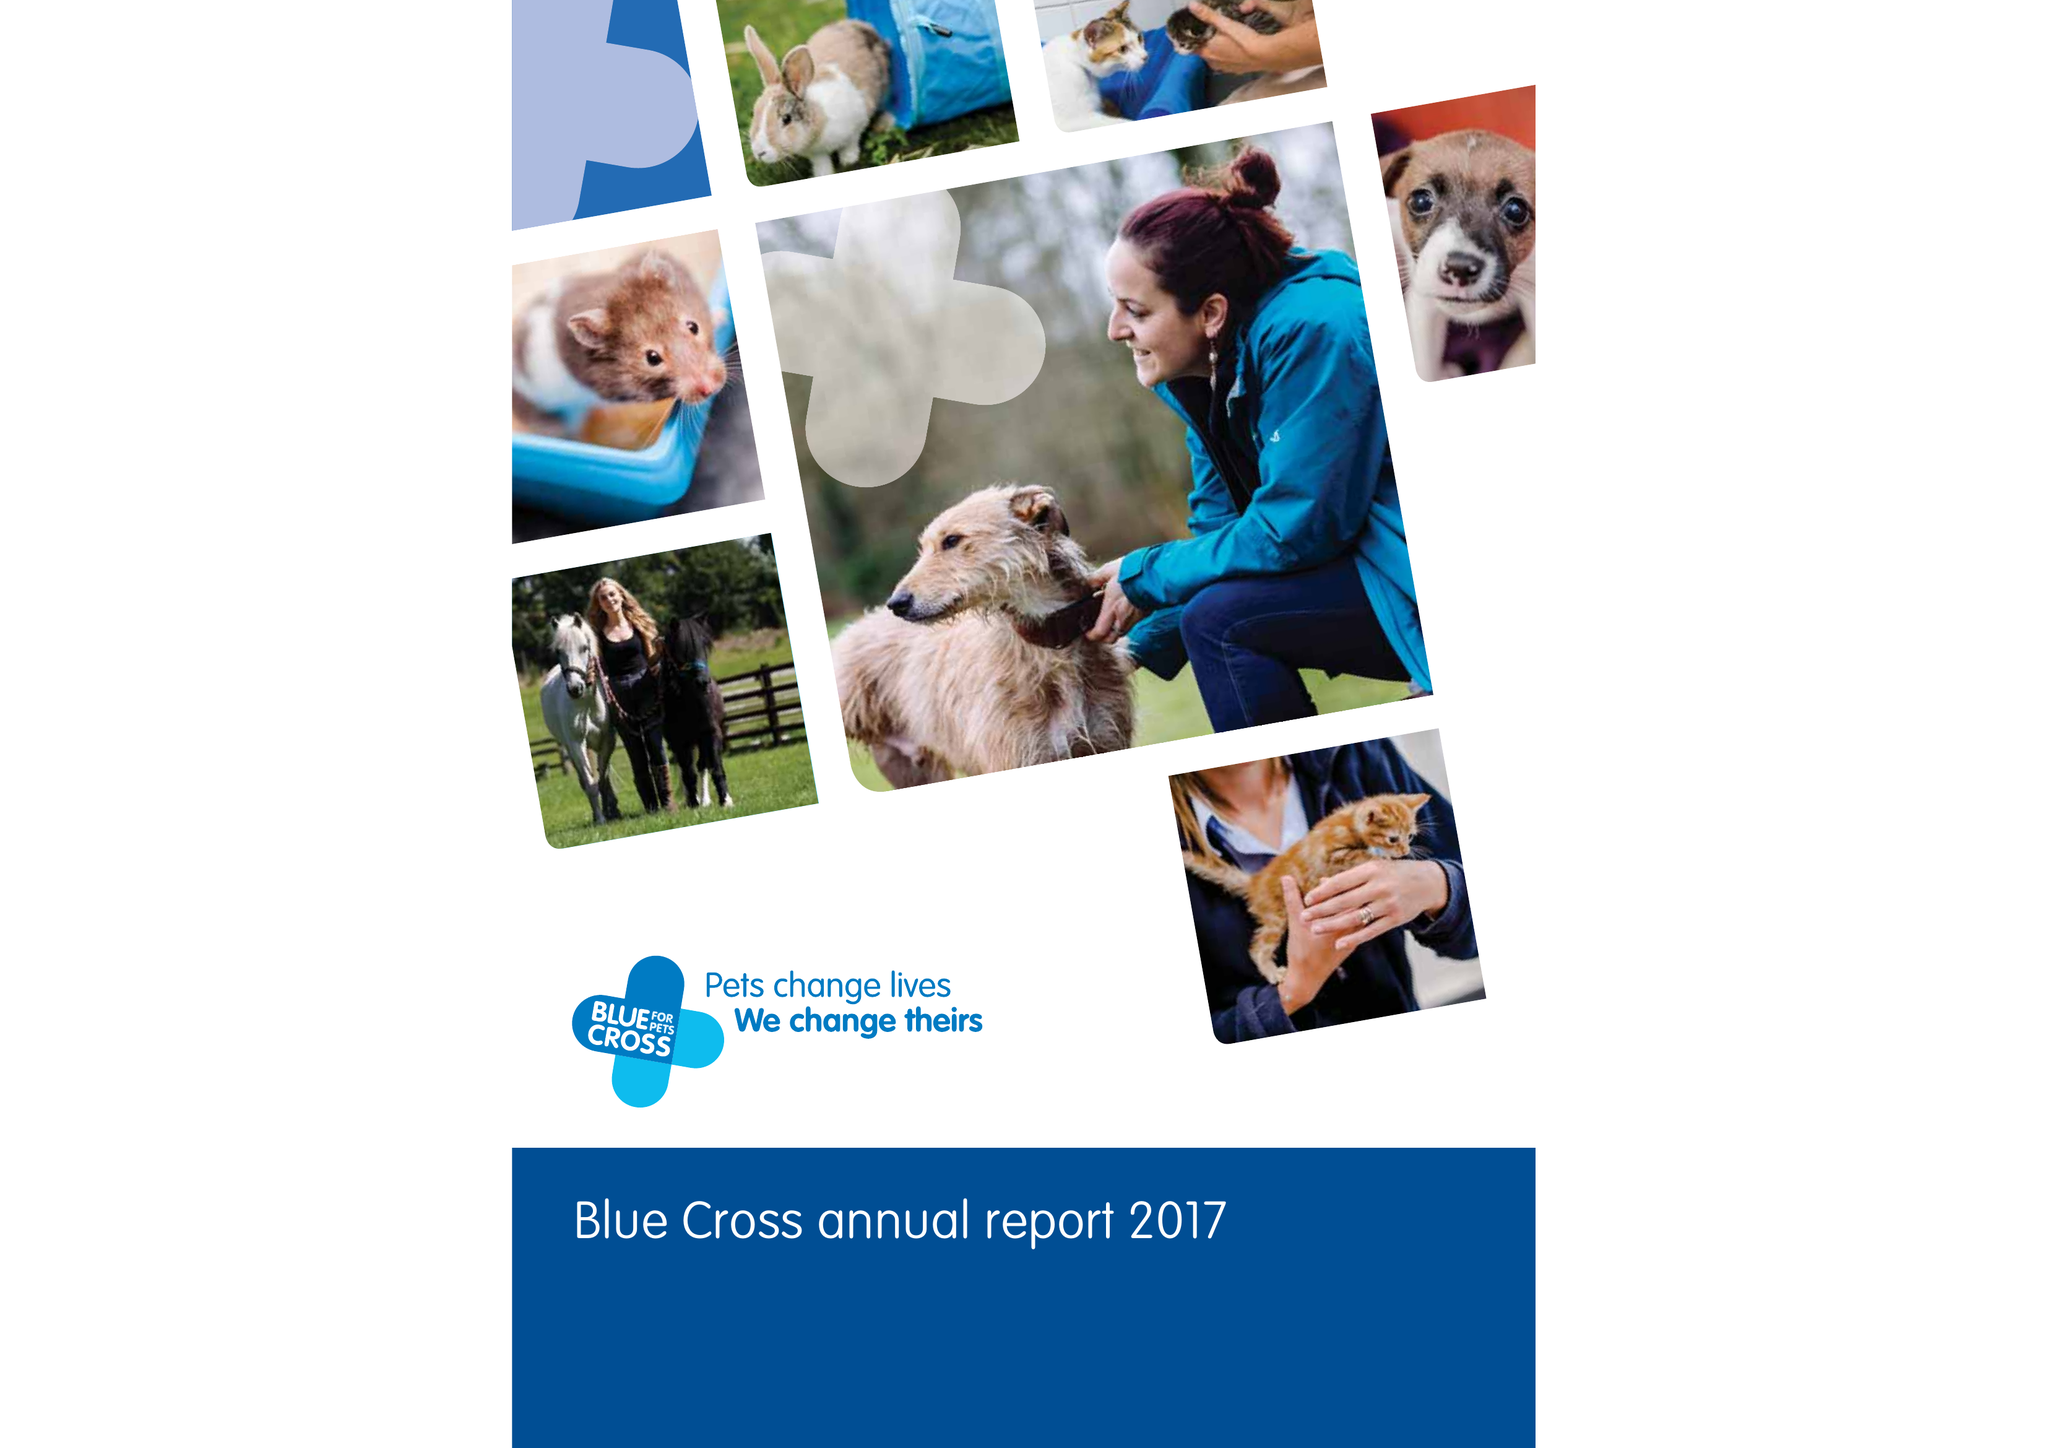What is the value for the charity_number?
Answer the question using a single word or phrase. 224392 